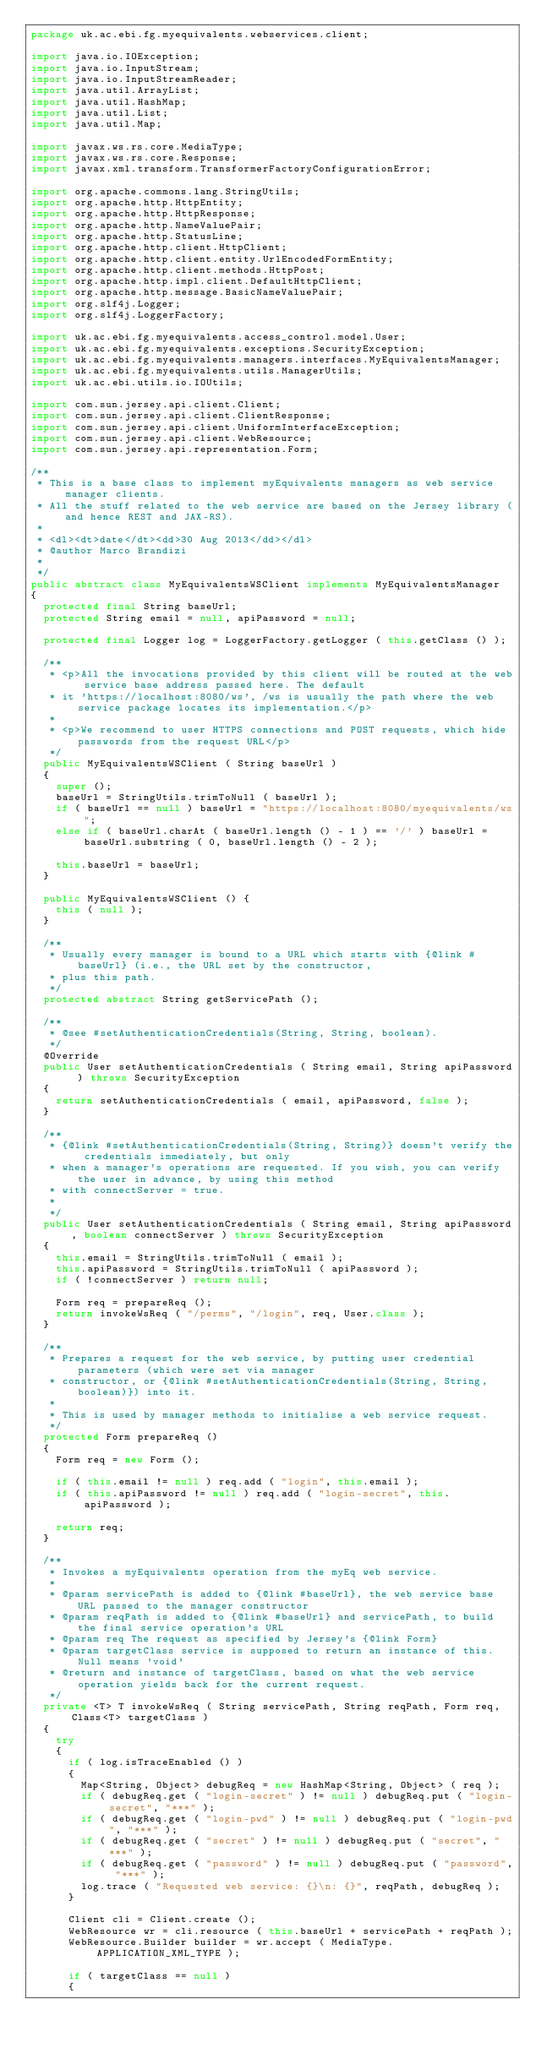Convert code to text. <code><loc_0><loc_0><loc_500><loc_500><_Java_>package uk.ac.ebi.fg.myequivalents.webservices.client;

import java.io.IOException;
import java.io.InputStream;
import java.io.InputStreamReader;
import java.util.ArrayList;
import java.util.HashMap;
import java.util.List;
import java.util.Map;

import javax.ws.rs.core.MediaType;
import javax.ws.rs.core.Response;
import javax.xml.transform.TransformerFactoryConfigurationError;

import org.apache.commons.lang.StringUtils;
import org.apache.http.HttpEntity;
import org.apache.http.HttpResponse;
import org.apache.http.NameValuePair;
import org.apache.http.StatusLine;
import org.apache.http.client.HttpClient;
import org.apache.http.client.entity.UrlEncodedFormEntity;
import org.apache.http.client.methods.HttpPost;
import org.apache.http.impl.client.DefaultHttpClient;
import org.apache.http.message.BasicNameValuePair;
import org.slf4j.Logger;
import org.slf4j.LoggerFactory;

import uk.ac.ebi.fg.myequivalents.access_control.model.User;
import uk.ac.ebi.fg.myequivalents.exceptions.SecurityException;
import uk.ac.ebi.fg.myequivalents.managers.interfaces.MyEquivalentsManager;
import uk.ac.ebi.fg.myequivalents.utils.ManagerUtils;
import uk.ac.ebi.utils.io.IOUtils;

import com.sun.jersey.api.client.Client;
import com.sun.jersey.api.client.ClientResponse;
import com.sun.jersey.api.client.UniformInterfaceException;
import com.sun.jersey.api.client.WebResource;
import com.sun.jersey.api.representation.Form;

/**
 * This is a base class to implement myEquivalents managers as web service manager clients.
 * All the stuff related to the web service are based on the Jersey library (and hence REST and JAX-RS). 
 *
 * <dl><dt>date</dt><dd>30 Aug 2013</dd></dl>
 * @author Marco Brandizi
 *
 */
public abstract class MyEquivalentsWSClient implements MyEquivalentsManager
{
	protected final String baseUrl;
	protected String email = null, apiPassword = null;

	protected final Logger log = LoggerFactory.getLogger ( this.getClass () );
	
	/**
	 * <p>All the invocations provided by this client will be routed at the web service base address passed here. The default
	 * it 'https://localhost:8080/ws', /ws is usually the path where the web service package locates its implementation.</p>
	 * 
	 * <p>We recommend to user HTTPS connections and POST requests, which hide passwords from the request URL</p>
	 */
	public MyEquivalentsWSClient ( String baseUrl )
	{
		super ();
		baseUrl = StringUtils.trimToNull ( baseUrl );
		if ( baseUrl == null ) baseUrl = "https://localhost:8080/myequivalents/ws";
		else if ( baseUrl.charAt ( baseUrl.length () - 1 ) == '/' ) baseUrl = baseUrl.substring ( 0, baseUrl.length () - 2 );
		
		this.baseUrl = baseUrl;
	}

	public MyEquivalentsWSClient () {
		this ( null );
	}

	/**
	 * Usually every manager is bound to a URL which starts with {@link #baseUrl} (i.e., the URL set by the constructor, 
	 * plus this path.
	 */
	protected abstract String getServicePath ();
	
	/**
	 * @see #setAuthenticationCredentials(String, String, boolean).
	 */
	@Override
	public User setAuthenticationCredentials ( String email, String apiPassword ) throws SecurityException
	{
		return setAuthenticationCredentials ( email, apiPassword, false );
	}

	/**
	 * {@link #setAuthenticationCredentials(String, String)} doesn't verify the credentials immediately, but only 
	 * when a manager's operations are requested. If you wish, you can verify the user in advance, by using this method
	 * with connectServer = true. 
	 * 
	 */
	public User setAuthenticationCredentials ( String email, String apiPassword, boolean connectServer ) throws SecurityException
	{
		this.email = StringUtils.trimToNull ( email );
		this.apiPassword = StringUtils.trimToNull ( apiPassword );
		if ( !connectServer ) return null;
					
		Form req = prepareReq ();
		return invokeWsReq ( "/perms", "/login", req, User.class );
	}

	/**
	 * Prepares a request for the web service, by putting user credential parameters (which were set via manager 
	 * constructor, or {@link #setAuthenticationCredentials(String, String, boolean)}) into it. 
	 * 
	 * This is used by manager methods to initialise a web service request.  
	 */
	protected Form prepareReq ()
	{
		Form req = new Form ();
		
		if ( this.email != null ) req.add ( "login", this.email );
		if ( this.apiPassword != null ) req.add ( "login-secret", this.apiPassword );

		return req;
	}
	
	/**
	 * Invokes a myEquivalents operation from the myEq web service.
	 *  
	 * @param servicePath is added to {@link #baseUrl}, the web service base URL passed to the manager constructor 
	 * @param reqPath is added to {@link #baseUrl} and servicePath, to build the final service operation's URL 
	 * @param req	The request as specified by Jersey's {@link Form}
	 * @param targetClass service is supposed to return an instance of this. Null means 'void'  
	 * @return and instance of targetClass, based on what the web service operation yields back for the current request.
	 */
	private <T> T invokeWsReq ( String servicePath, String reqPath, Form req, Class<T> targetClass )
	{
		try
		{
		  if ( log.isTraceEnabled () ) 
		  {
		  	Map<String, Object> debugReq = new HashMap<String, Object> ( req );
		  	if ( debugReq.get ( "login-secret" ) != null ) debugReq.put ( "login-secret", "***" );
		  	if ( debugReq.get ( "login-pwd" ) != null ) debugReq.put ( "login-pwd", "***" );
		  	if ( debugReq.get ( "secret" ) != null ) debugReq.put ( "secret", "***" );
		  	if ( debugReq.get ( "password" ) != null ) debugReq.put ( "password", "***" );
		  	log.trace ( "Requested web service: {}\n: {}", reqPath, debugReq );
		  }

			Client cli = Client.create ();
			WebResource wr = cli.resource ( this.baseUrl + servicePath + reqPath );
			WebResource.Builder builder = wr.accept ( MediaType.APPLICATION_XML_TYPE );
			
			if ( targetClass == null ) 
			{</code> 